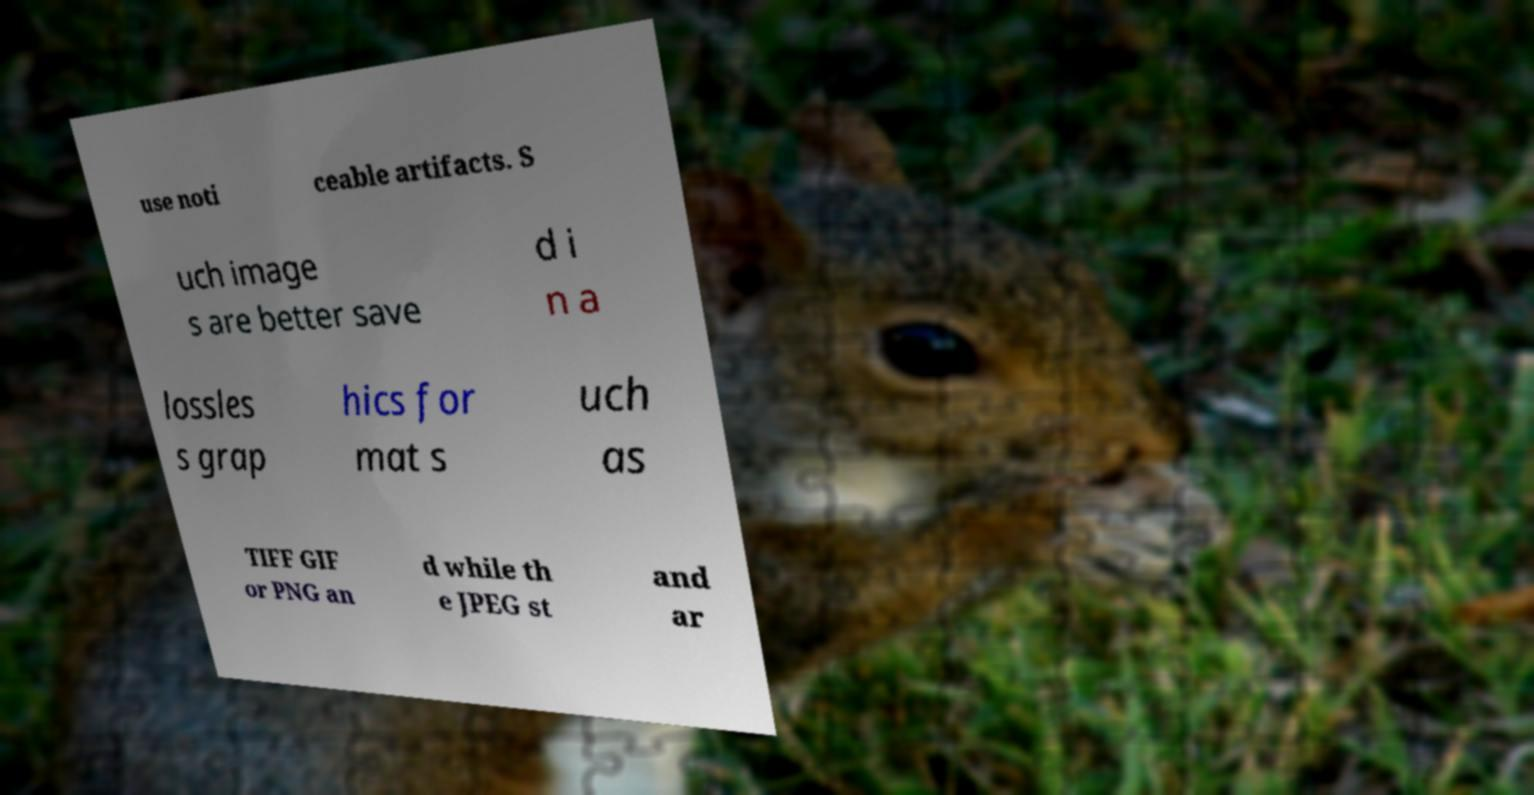What messages or text are displayed in this image? I need them in a readable, typed format. use noti ceable artifacts. S uch image s are better save d i n a lossles s grap hics for mat s uch as TIFF GIF or PNG an d while th e JPEG st and ar 